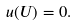Convert formula to latex. <formula><loc_0><loc_0><loc_500><loc_500>u ( U ) = 0 .</formula> 